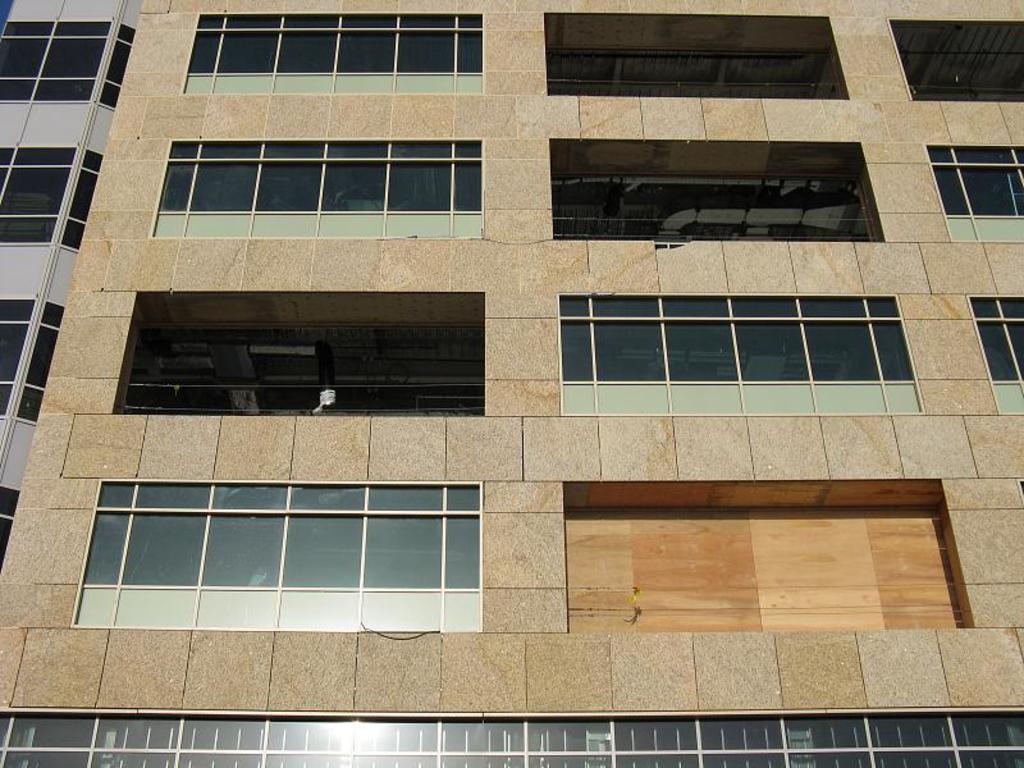In one or two sentences, can you explain what this image depicts? In this picture, we see a building. It has glass windows. On the left side, we see a building in white and black color. 